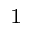Convert formula to latex. <formula><loc_0><loc_0><loc_500><loc_500>_ { 1 }</formula> 